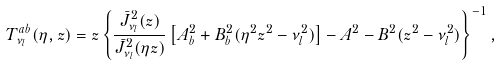<formula> <loc_0><loc_0><loc_500><loc_500>T _ { \nu _ { l } } ^ { a b } ( \eta , z ) = z \left \{ \frac { \bar { J } _ { \nu _ { l } } ^ { 2 } ( z ) } { \bar { J } _ { \nu _ { l } } ^ { 2 } ( \eta z ) } \left [ A ^ { 2 } _ { b } + B ^ { 2 } _ { b } ( \eta ^ { 2 } z ^ { 2 } - \nu _ { l } ^ { 2 } ) \right ] - A ^ { 2 } - B ^ { 2 } ( z ^ { 2 } - \nu _ { l } ^ { 2 } ) \right \} ^ { - 1 } ,</formula> 